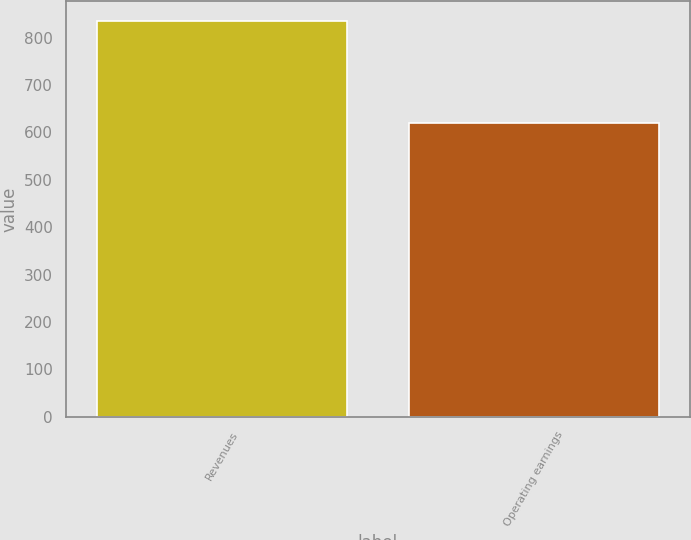Convert chart to OTSL. <chart><loc_0><loc_0><loc_500><loc_500><bar_chart><fcel>Revenues<fcel>Operating earnings<nl><fcel>835<fcel>620<nl></chart> 